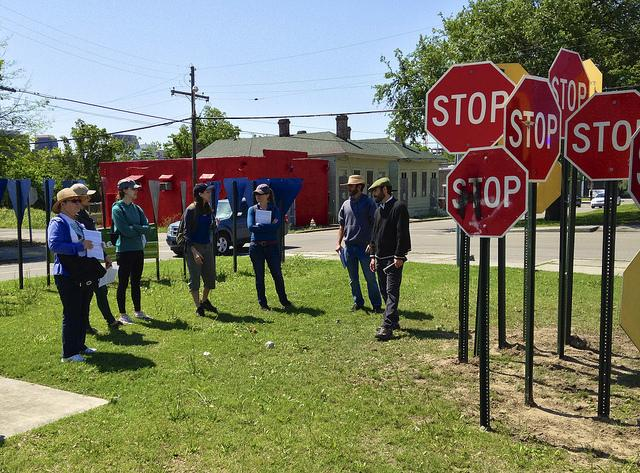Who created the works seen here? artist 